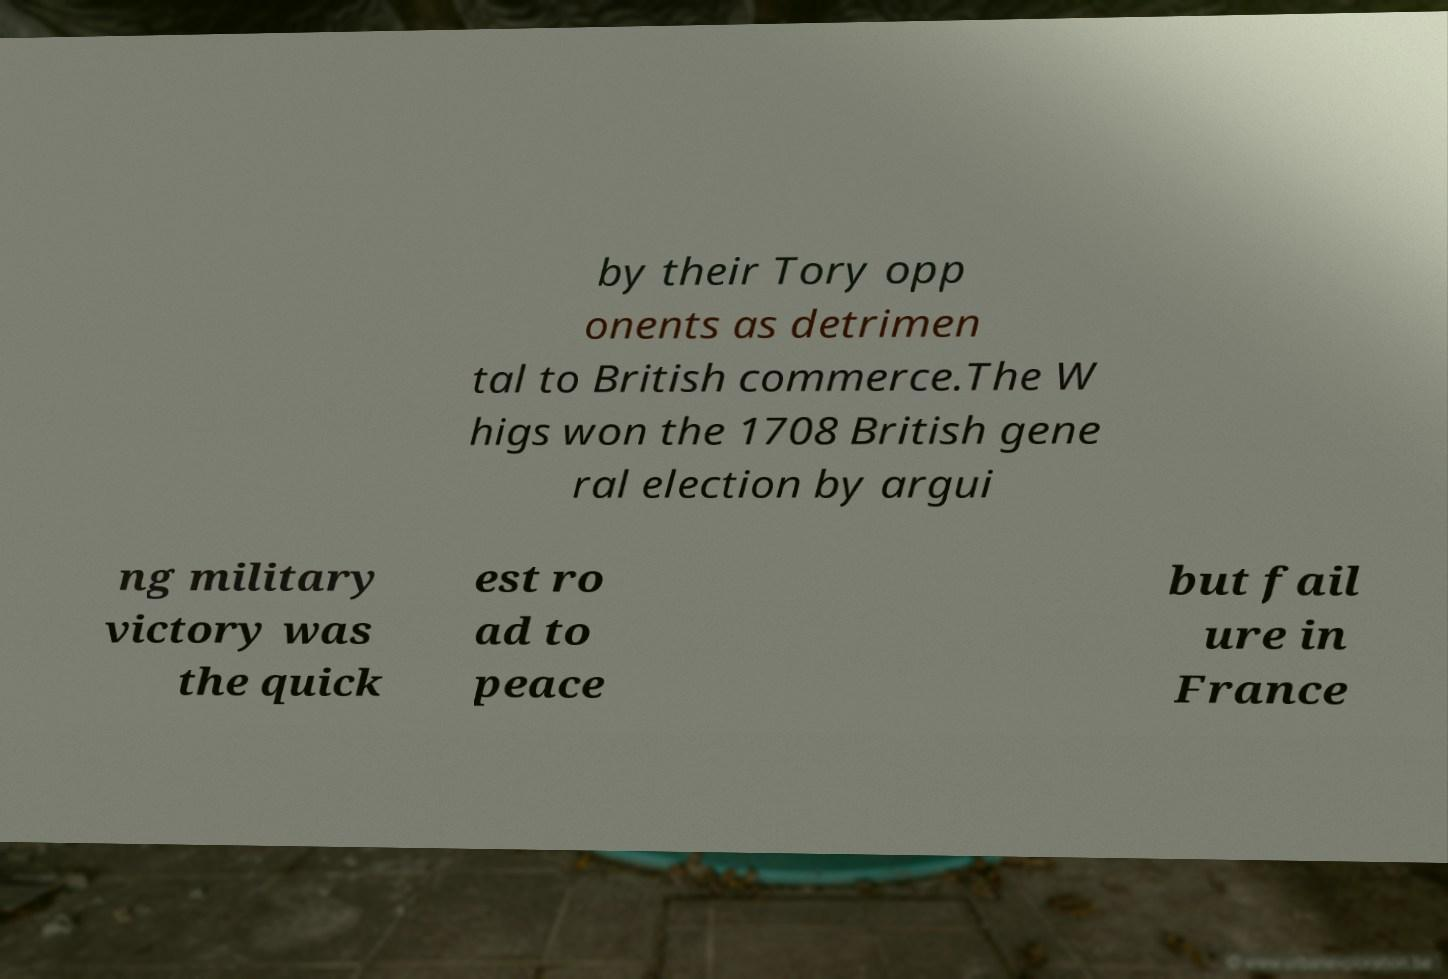For documentation purposes, I need the text within this image transcribed. Could you provide that? by their Tory opp onents as detrimen tal to British commerce.The W higs won the 1708 British gene ral election by argui ng military victory was the quick est ro ad to peace but fail ure in France 